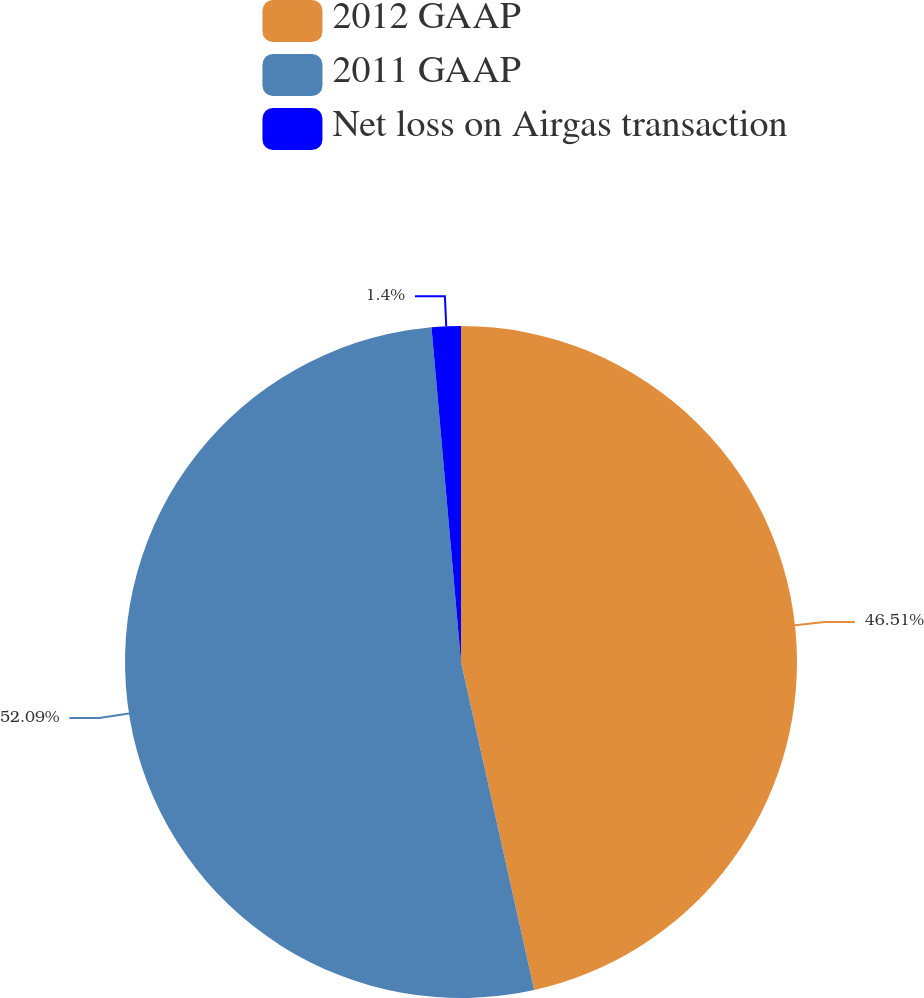<chart> <loc_0><loc_0><loc_500><loc_500><pie_chart><fcel>2012 GAAP<fcel>2011 GAAP<fcel>Net loss on Airgas transaction<nl><fcel>46.51%<fcel>52.1%<fcel>1.4%<nl></chart> 